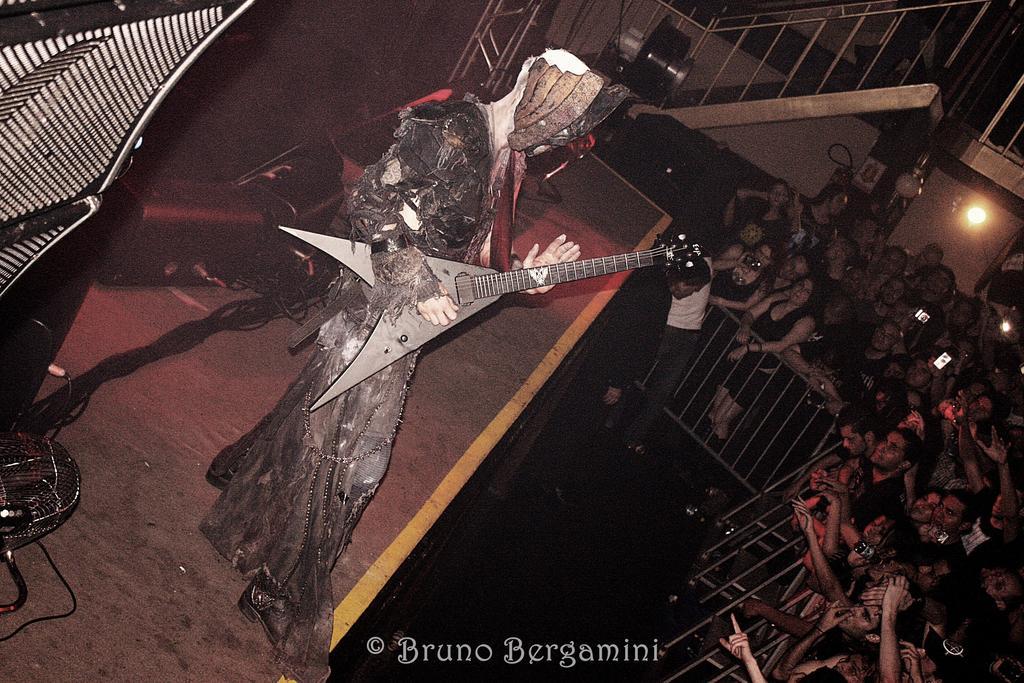How would you summarize this image in a sentence or two? In this image we can see a few people, some of them are holding cell phones, there is a person wearing different costume is standing on the stage, he is holding a guitar, there is a fencing, staircase, handrail, there are electronic objects on the stage, also we can see the lights. 